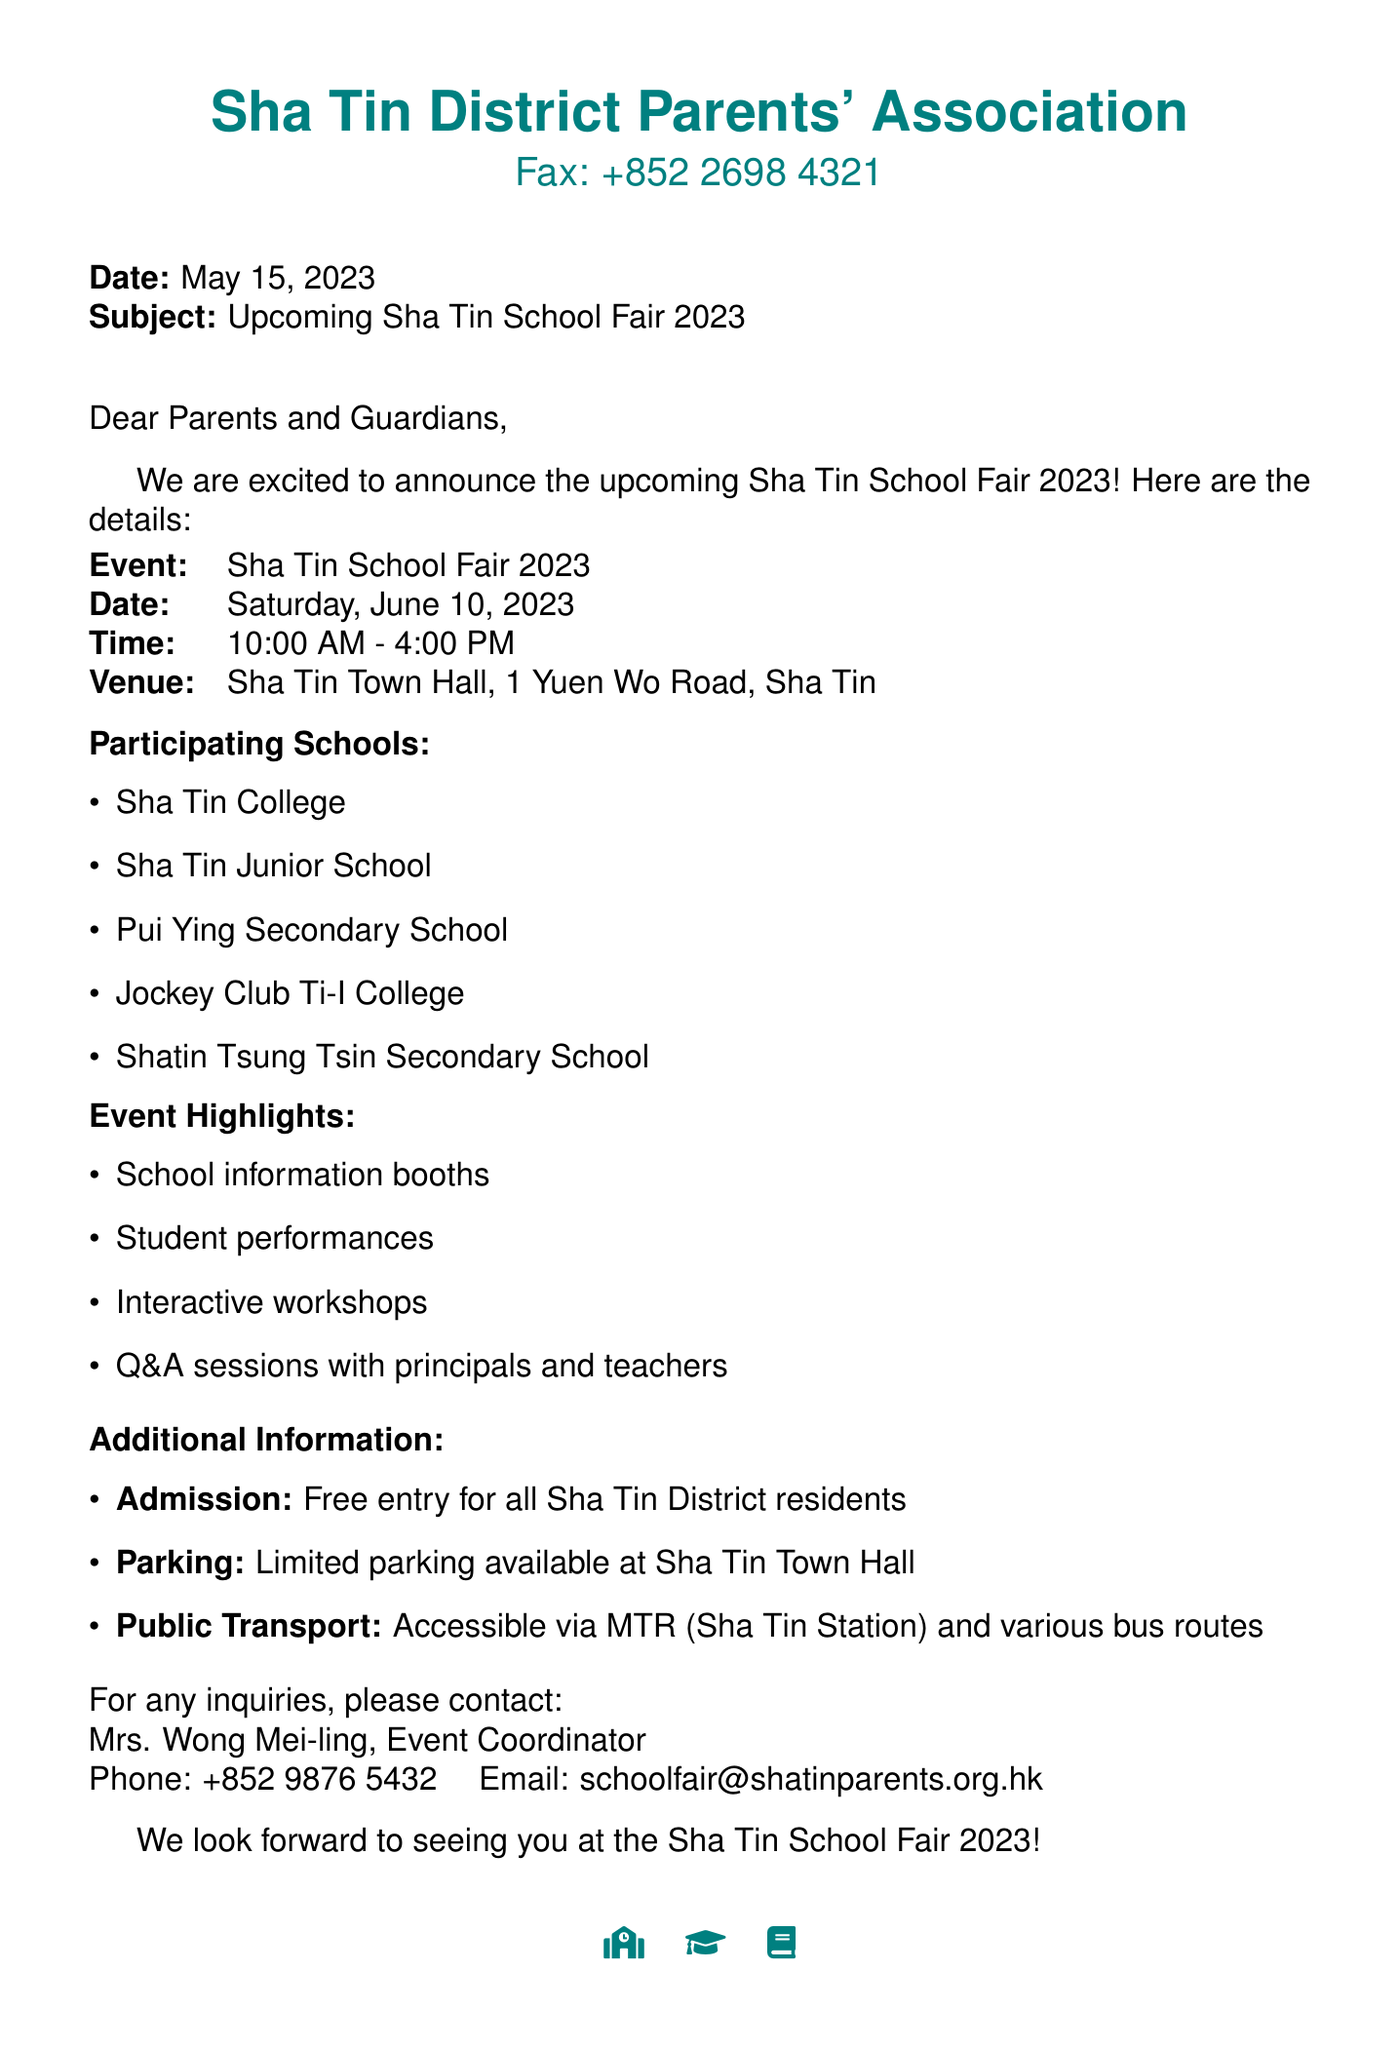What is the date of the event? The date of the Sha Tin School Fair 2023 is explicitly stated in the document.
Answer: Saturday, June 10, 2023 What time does the fair start? The time for the start of the fair is provided in the document.
Answer: 10:00 AM Where is the venue located? The document specifies the venue location for the school fair.
Answer: Sha Tin Town Hall, 1 Yuen Wo Road, Sha Tin Which schools are participating? The participating schools are listed in a bullet format in the document.
Answer: Sha Tin College, Sha Tin Junior School, Pui Ying Secondary School, Jockey Club Ti-I College, Shatin Tsung Tsin Secondary School Is the admission fee applicable? The document explicitly mentions the admission fee details for the event.
Answer: Free entry for all Sha Tin District residents What activities are featured at the event? The document lists the event highlights which include various activities.
Answer: School information booths, Student performances, Interactive workshops, Q&A sessions with principals and teachers Who can be contacted for inquiries? The document provides contact information for the event coordinator.
Answer: Mrs. Wong Mei-ling What is the parking situation? The document includes information regarding parking availability at the venue.
Answer: Limited parking available at Sha Tin Town Hall How can attendees access the venue? The document mentions options for public transport access to the venue.
Answer: Accessible via MTR (Sha Tin Station) and various bus routes 